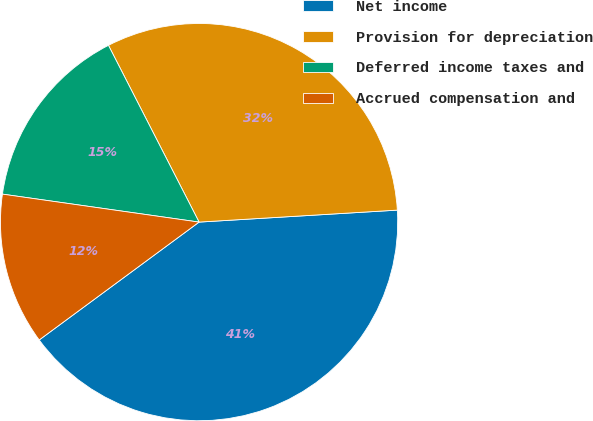<chart> <loc_0><loc_0><loc_500><loc_500><pie_chart><fcel>Net income<fcel>Provision for depreciation<fcel>Deferred income taxes and<fcel>Accrued compensation and<nl><fcel>40.85%<fcel>31.58%<fcel>15.21%<fcel>12.36%<nl></chart> 